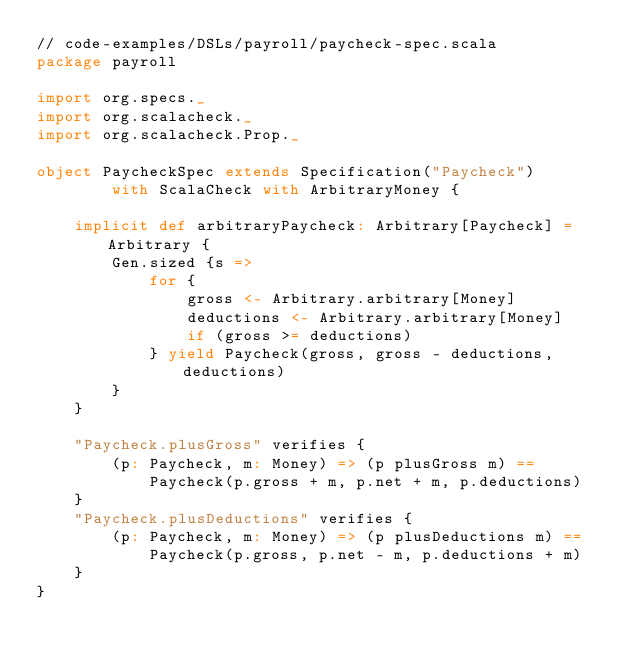<code> <loc_0><loc_0><loc_500><loc_500><_Scala_>// code-examples/DSLs/payroll/paycheck-spec.scala
package payroll

import org.specs._ 
import org.scalacheck._
import org.scalacheck.Prop._

object PaycheckSpec extends Specification("Paycheck") 
        with ScalaCheck with ArbitraryMoney { 

    implicit def arbitraryPaycheck: Arbitrary[Paycheck] = Arbitrary {
        Gen.sized {s => 
            for { 
                gross <- Arbitrary.arbitrary[Money]
                deductions <- Arbitrary.arbitrary[Money]
                if (gross >= deductions)
            } yield Paycheck(gross, gross - deductions, deductions)
        }
    }
    
    "Paycheck.plusGross" verifies { 
        (p: Paycheck, m: Money) => (p plusGross m) == 
            Paycheck(p.gross + m, p.net + m, p.deductions)
    }
    "Paycheck.plusDeductions" verifies { 
        (p: Paycheck, m: Money) => (p plusDeductions m) == 
            Paycheck(p.gross, p.net - m, p.deductions + m)
    }
}</code> 